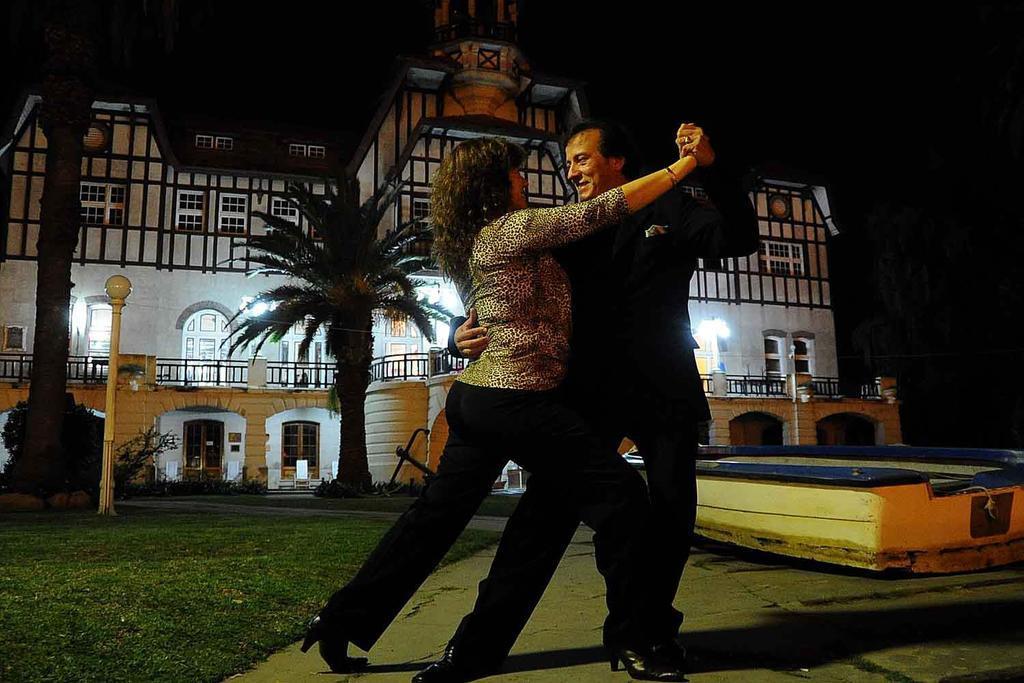In one or two sentences, can you explain what this image depicts? In this image I can see two persons. The person at left is wearing brown and black color dress and the person at right is wearing black color dress. In the background I can see few light poles, trees and I can also see the building and the sky is in black color. 